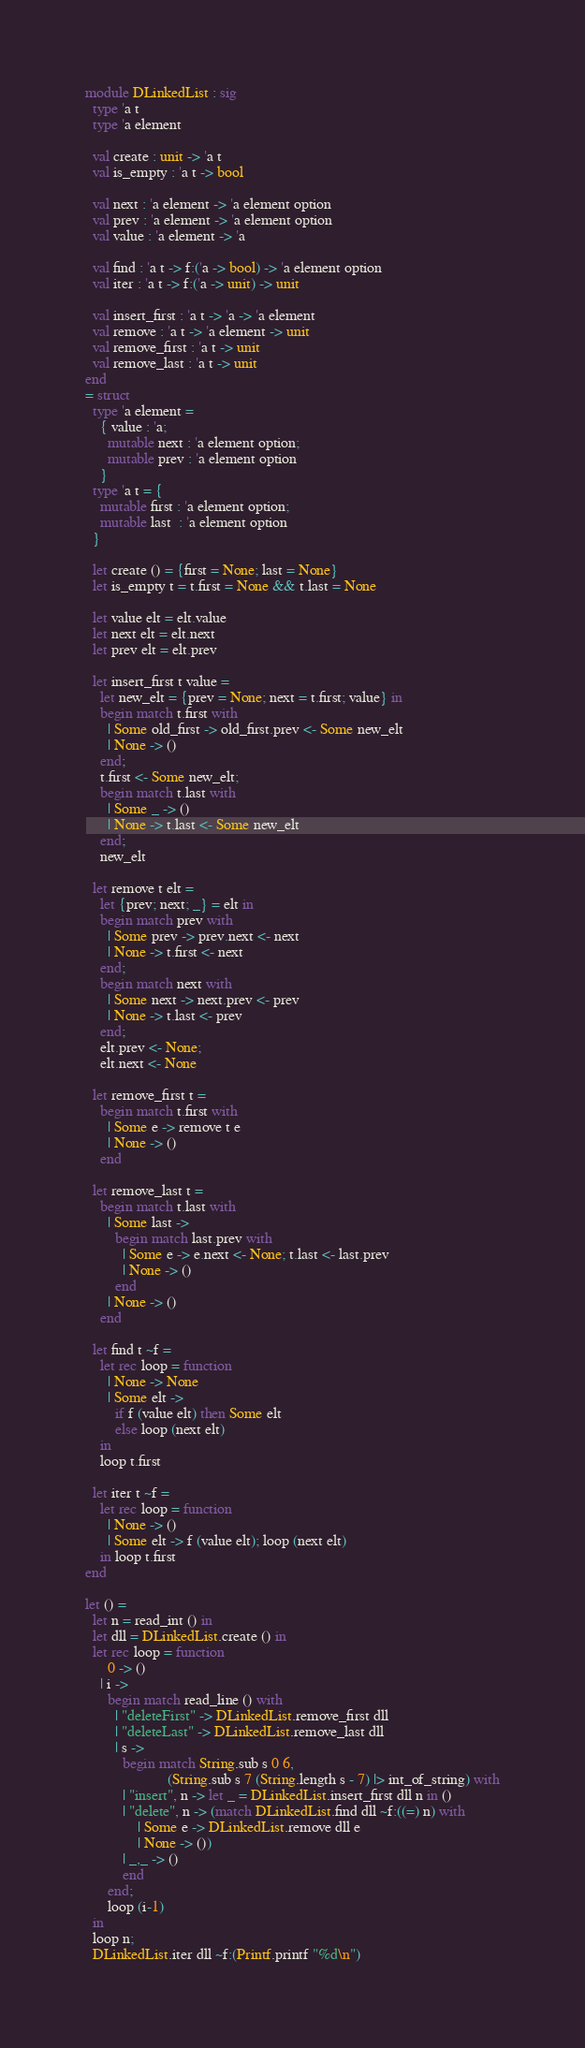Convert code to text. <code><loc_0><loc_0><loc_500><loc_500><_OCaml_>module DLinkedList : sig
  type 'a t
  type 'a element

  val create : unit -> 'a t
  val is_empty : 'a t -> bool

  val next : 'a element -> 'a element option
  val prev : 'a element -> 'a element option
  val value : 'a element -> 'a

  val find : 'a t -> f:('a -> bool) -> 'a element option
  val iter : 'a t -> f:('a -> unit) -> unit

  val insert_first : 'a t -> 'a -> 'a element
  val remove : 'a t -> 'a element -> unit
  val remove_first : 'a t -> unit
  val remove_last : 'a t -> unit
end
= struct
  type 'a element =
    { value : 'a;
      mutable next : 'a element option;
      mutable prev : 'a element option
    }
  type 'a t = {
    mutable first : 'a element option;
    mutable last  : 'a element option
  }

  let create () = {first = None; last = None}
  let is_empty t = t.first = None && t.last = None

  let value elt = elt.value
  let next elt = elt.next
  let prev elt = elt.prev

  let insert_first t value =
    let new_elt = {prev = None; next = t.first; value} in
    begin match t.first with
      | Some old_first -> old_first.prev <- Some new_elt
      | None -> ()
    end;
    t.first <- Some new_elt;
    begin match t.last with
      | Some _ -> ()
      | None -> t.last <- Some new_elt
    end;
    new_elt

  let remove t elt =
    let {prev; next; _} = elt in
    begin match prev with
      | Some prev -> prev.next <- next
      | None -> t.first <- next
    end;
    begin match next with
      | Some next -> next.prev <- prev
      | None -> t.last <- prev
    end;
    elt.prev <- None;
    elt.next <- None

  let remove_first t =
    begin match t.first with
      | Some e -> remove t e
      | None -> ()
    end

  let remove_last t =
    begin match t.last with
      | Some last ->
        begin match last.prev with
          | Some e -> e.next <- None; t.last <- last.prev
          | None -> ()
        end
      | None -> ()
    end

  let find t ~f =
    let rec loop = function
      | None -> None
      | Some elt ->
        if f (value elt) then Some elt
        else loop (next elt)
    in
    loop t.first

  let iter t ~f =
    let rec loop = function
      | None -> ()
      | Some elt -> f (value elt); loop (next elt)
    in loop t.first
end

let () =
  let n = read_int () in
  let dll = DLinkedList.create () in
  let rec loop = function
      0 -> ()
    | i ->
      begin match read_line () with
        | "deleteFirst" -> DLinkedList.remove_first dll
        | "deleteLast" -> DLinkedList.remove_last dll
        | s ->
          begin match String.sub s 0 6,
                      (String.sub s 7 (String.length s - 7) |> int_of_string) with
          | "insert", n -> let _ = DLinkedList.insert_first dll n in ()
          | "delete", n -> (match DLinkedList.find dll ~f:((=) n) with
              | Some e -> DLinkedList.remove dll e
              | None -> ())
          | _,_ -> ()
          end
      end;
      loop (i-1)
  in
  loop n;
  DLinkedList.iter dll ~f:(Printf.printf "%d\n")</code> 